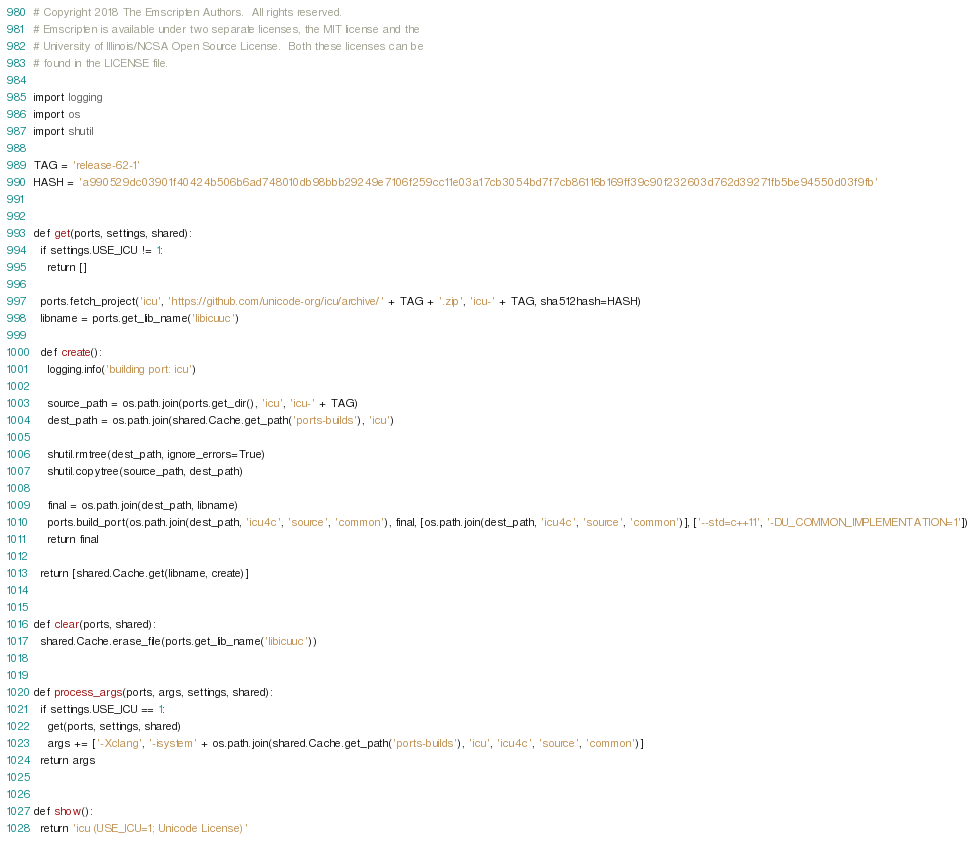Convert code to text. <code><loc_0><loc_0><loc_500><loc_500><_Python_># Copyright 2018 The Emscripten Authors.  All rights reserved.
# Emscripten is available under two separate licenses, the MIT license and the
# University of Illinois/NCSA Open Source License.  Both these licenses can be
# found in the LICENSE file.

import logging
import os
import shutil

TAG = 'release-62-1'
HASH = 'a990529dc03901f40424b506b6ad748010db98bbb29249e7106f259cc11e03a17cb3054bd7f7cb86116b169ff39c90f232603d762d39271fb5be94550d03f9fb'


def get(ports, settings, shared):
  if settings.USE_ICU != 1:
    return []

  ports.fetch_project('icu', 'https://github.com/unicode-org/icu/archive/' + TAG + '.zip', 'icu-' + TAG, sha512hash=HASH)
  libname = ports.get_lib_name('libicuuc')

  def create():
    logging.info('building port: icu')

    source_path = os.path.join(ports.get_dir(), 'icu', 'icu-' + TAG)
    dest_path = os.path.join(shared.Cache.get_path('ports-builds'), 'icu')

    shutil.rmtree(dest_path, ignore_errors=True)
    shutil.copytree(source_path, dest_path)

    final = os.path.join(dest_path, libname)
    ports.build_port(os.path.join(dest_path, 'icu4c', 'source', 'common'), final, [os.path.join(dest_path, 'icu4c', 'source', 'common')], ['--std=c++11', '-DU_COMMON_IMPLEMENTATION=1'])
    return final

  return [shared.Cache.get(libname, create)]


def clear(ports, shared):
  shared.Cache.erase_file(ports.get_lib_name('libicuuc'))


def process_args(ports, args, settings, shared):
  if settings.USE_ICU == 1:
    get(ports, settings, shared)
    args += ['-Xclang', '-isystem' + os.path.join(shared.Cache.get_path('ports-builds'), 'icu', 'icu4c', 'source', 'common')]
  return args


def show():
  return 'icu (USE_ICU=1; Unicode License)'
</code> 